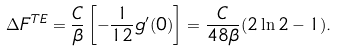<formula> <loc_0><loc_0><loc_500><loc_500>\Delta F ^ { T E } = \frac { C } { \beta } \left [ - \frac { 1 } { 1 2 } g ^ { \prime } ( 0 ) \right ] = \frac { C } { 4 8 \beta } ( 2 \ln 2 - 1 ) .</formula> 